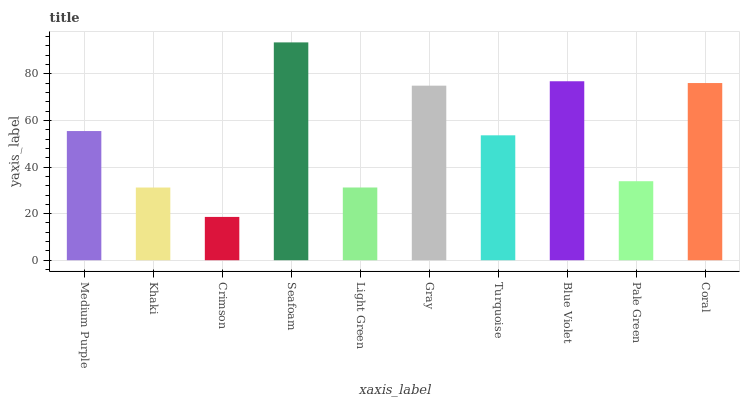Is Khaki the minimum?
Answer yes or no. No. Is Khaki the maximum?
Answer yes or no. No. Is Medium Purple greater than Khaki?
Answer yes or no. Yes. Is Khaki less than Medium Purple?
Answer yes or no. Yes. Is Khaki greater than Medium Purple?
Answer yes or no. No. Is Medium Purple less than Khaki?
Answer yes or no. No. Is Medium Purple the high median?
Answer yes or no. Yes. Is Turquoise the low median?
Answer yes or no. Yes. Is Crimson the high median?
Answer yes or no. No. Is Khaki the low median?
Answer yes or no. No. 